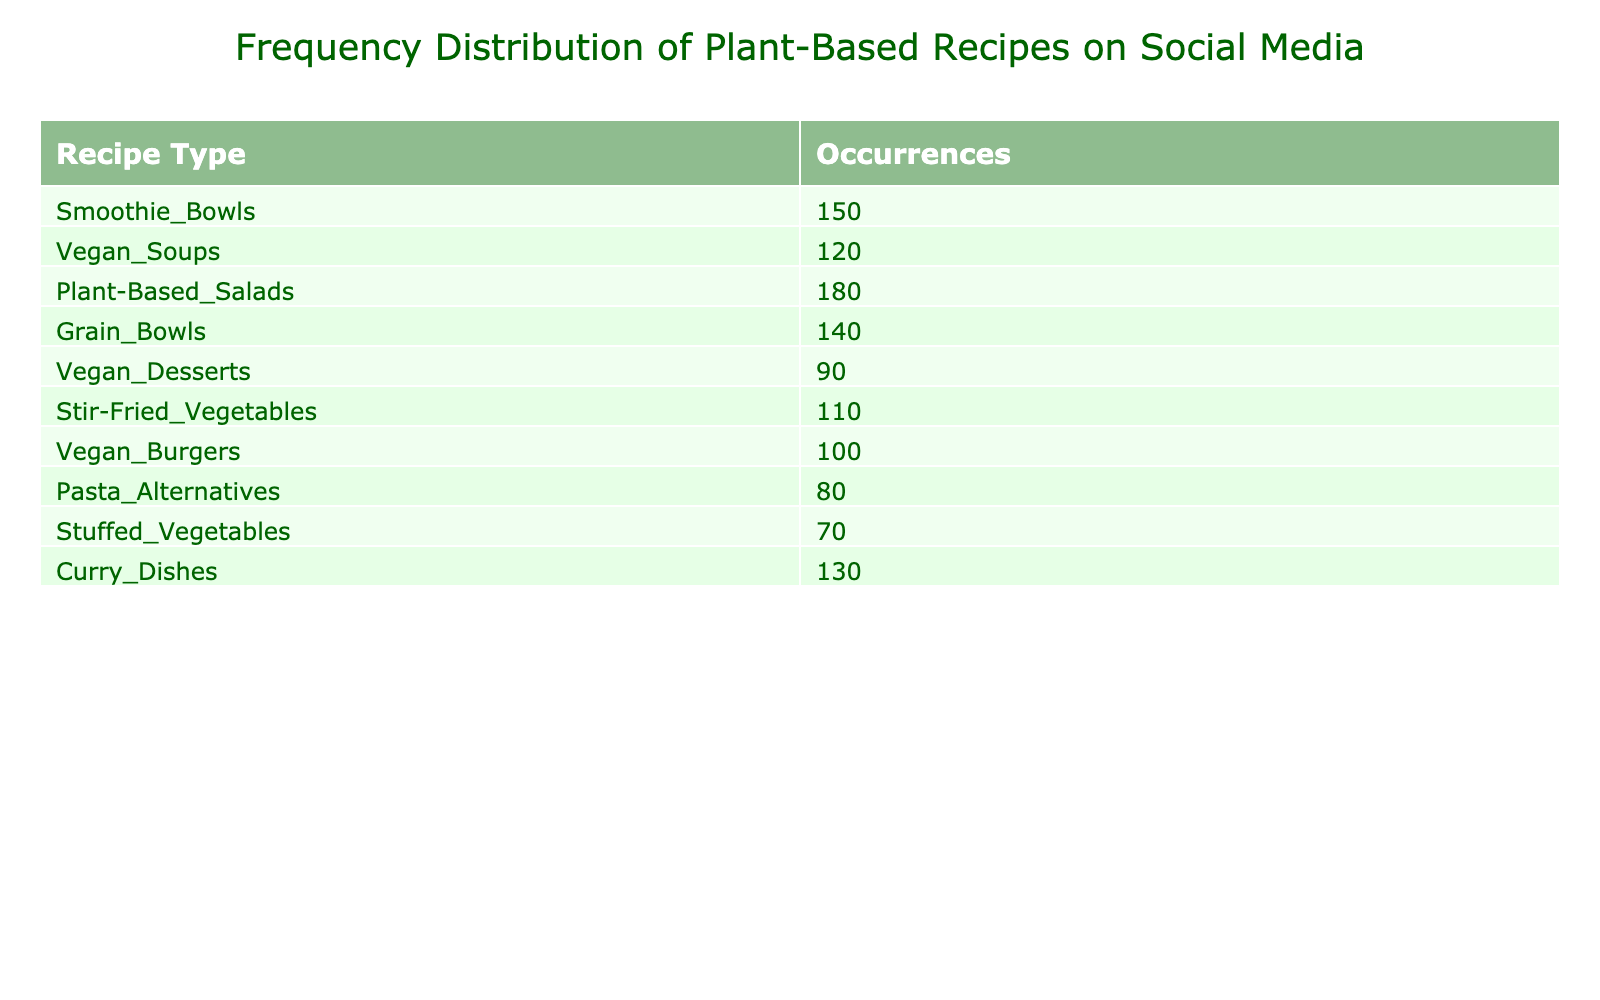What is the highest occurring recipe type? By inspecting the "Occurrences" column in the table, the highest number is 180, which corresponds to the "Plant-Based Salads" row.
Answer: Plant-Based Salads How many occurrences do Vegan Desserts have? Looking directly at the table, the row for "Vegan Desserts" shows 90 occurrences.
Answer: 90 What is the average occurrence of all recipe types? To find the average, sum all the occurrences: (150 + 120 + 180 + 140 + 90 + 110 + 100 + 80 + 70 + 130) = 1,200. There are 10 recipe types, so the average is 1,200 / 10 = 120.
Answer: 120 Is there a recipe type with more than 150 occurrences? By checking the occurrences, "Plant-Based Salads" (180) and "Smoothie Bowls" (150) have occurrences greater than 150, confirming that some recipe types fit this criteria.
Answer: Yes What is the difference in occurrences between the recipe type with the highest and the lowest occurrences? The highest occurrence is from "Plant-Based Salads" (180) and the lowest is "Stuffed Vegetables" (70). The difference is 180 - 70 = 110.
Answer: 110 Which recipe type has occurrences between 100 and 130? By scanning the table, "Stir-Fried Vegetables" (110) and "Curry Dishes" (130) are within that range, while others do not fit.
Answer: Stir-Fried Vegetables, Curry Dishes How many recipe types have occurrences less than 100? Looking through the table, "Pasta Alternatives" (80) and "Stuffed Vegetables" (70) are the only ones with less than 100 occurrences, totaling 2 recipe types.
Answer: 2 Is the occurrence count for Vegan Burgers higher than that of Grain Bowls? "Vegan Burgers" has 100 occurrences, while "Grain Bowls" has 140. Since 100 is less than 140, the statement is not true.
Answer: No What is the total number of occurrences of all the recipe types that start with 'Vegan'? The "Vegan" types and their occurrences are: "Vegan Soups" (120), "Vegan Desserts" (90), and "Vegan Burgers" (100). The sum is 120 + 90 + 100 = 310.
Answer: 310 